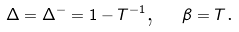<formula> <loc_0><loc_0><loc_500><loc_500>\Delta = \Delta ^ { - } = 1 - T ^ { - 1 } \text {,} \quad \beta = T \text {.}</formula> 